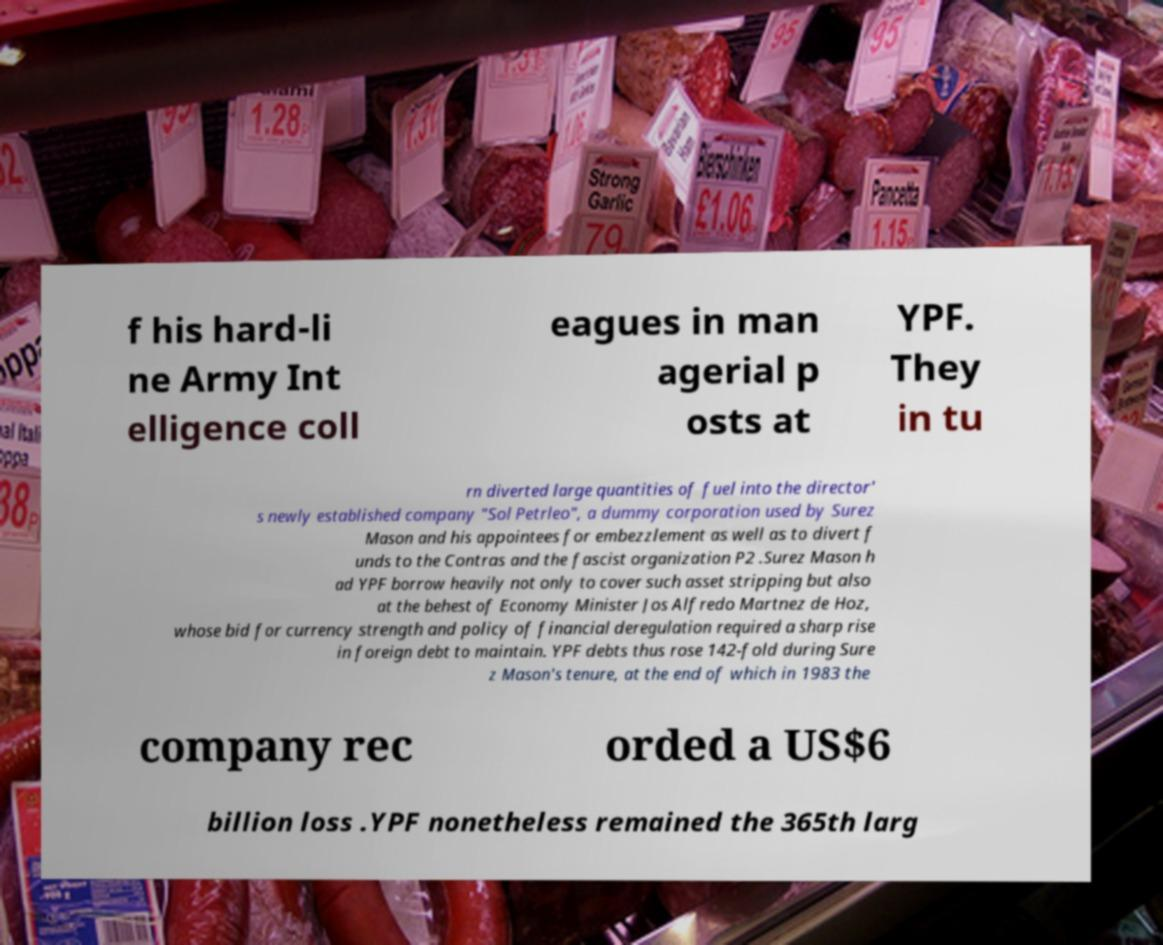Could you assist in decoding the text presented in this image and type it out clearly? f his hard-li ne Army Int elligence coll eagues in man agerial p osts at YPF. They in tu rn diverted large quantities of fuel into the director' s newly established company "Sol Petrleo", a dummy corporation used by Surez Mason and his appointees for embezzlement as well as to divert f unds to the Contras and the fascist organization P2 .Surez Mason h ad YPF borrow heavily not only to cover such asset stripping but also at the behest of Economy Minister Jos Alfredo Martnez de Hoz, whose bid for currency strength and policy of financial deregulation required a sharp rise in foreign debt to maintain. YPF debts thus rose 142-fold during Sure z Mason's tenure, at the end of which in 1983 the company rec orded a US$6 billion loss .YPF nonetheless remained the 365th larg 